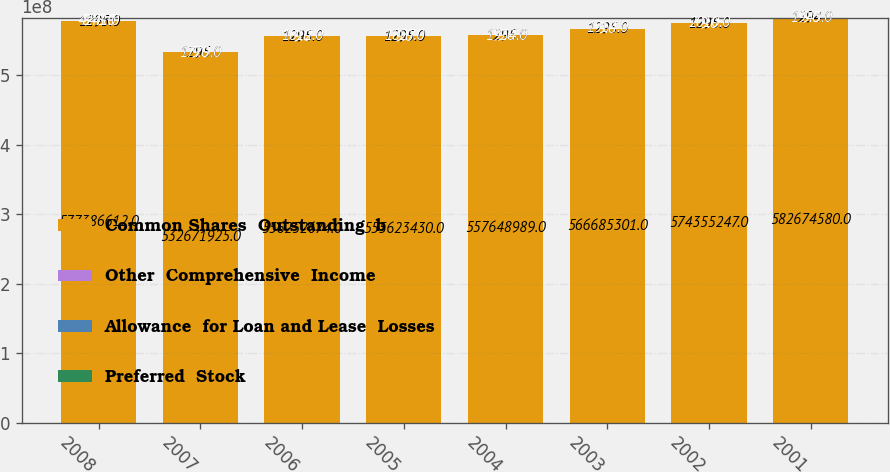Convert chart to OTSL. <chart><loc_0><loc_0><loc_500><loc_500><stacked_bar_chart><ecel><fcel>2008<fcel>2007<fcel>2006<fcel>2005<fcel>2004<fcel>2003<fcel>2002<fcel>2001<nl><fcel>Common Shares  Outstanding  b<fcel>5.77387e+08<fcel>5.32672e+08<fcel>5.56253e+08<fcel>5.55623e+08<fcel>5.57649e+08<fcel>5.66685e+08<fcel>5.74355e+08<fcel>5.82675e+08<nl><fcel>Other  Comprehensive  Income<fcel>1295<fcel>1295<fcel>1295<fcel>1295<fcel>1295<fcel>1295<fcel>1295<fcel>1294<nl><fcel>Allowance  for Loan and Lease  Losses<fcel>4241<fcel>9<fcel>9<fcel>9<fcel>9<fcel>9<fcel>9<fcel>9<nl><fcel>Preferred  Stock<fcel>848<fcel>1779<fcel>1812<fcel>1827<fcel>1934<fcel>1964<fcel>2010<fcel>1943<nl></chart> 